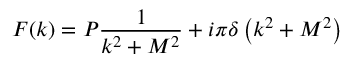<formula> <loc_0><loc_0><loc_500><loc_500>F ( k ) = P \frac { 1 } { k ^ { 2 } + M ^ { 2 } } + i \pi \delta \left ( k ^ { 2 } + M ^ { 2 } \right )</formula> 